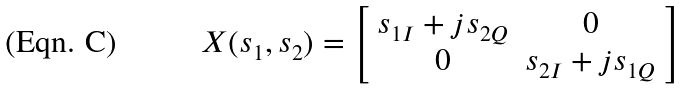Convert formula to latex. <formula><loc_0><loc_0><loc_500><loc_500>X ( s _ { 1 } , s _ { 2 } ) = \left [ \begin{array} { c c } s _ { 1 I } + j s _ { 2 Q } & 0 \\ 0 & s _ { 2 I } + j s _ { 1 Q } \\ \end{array} \right ]</formula> 